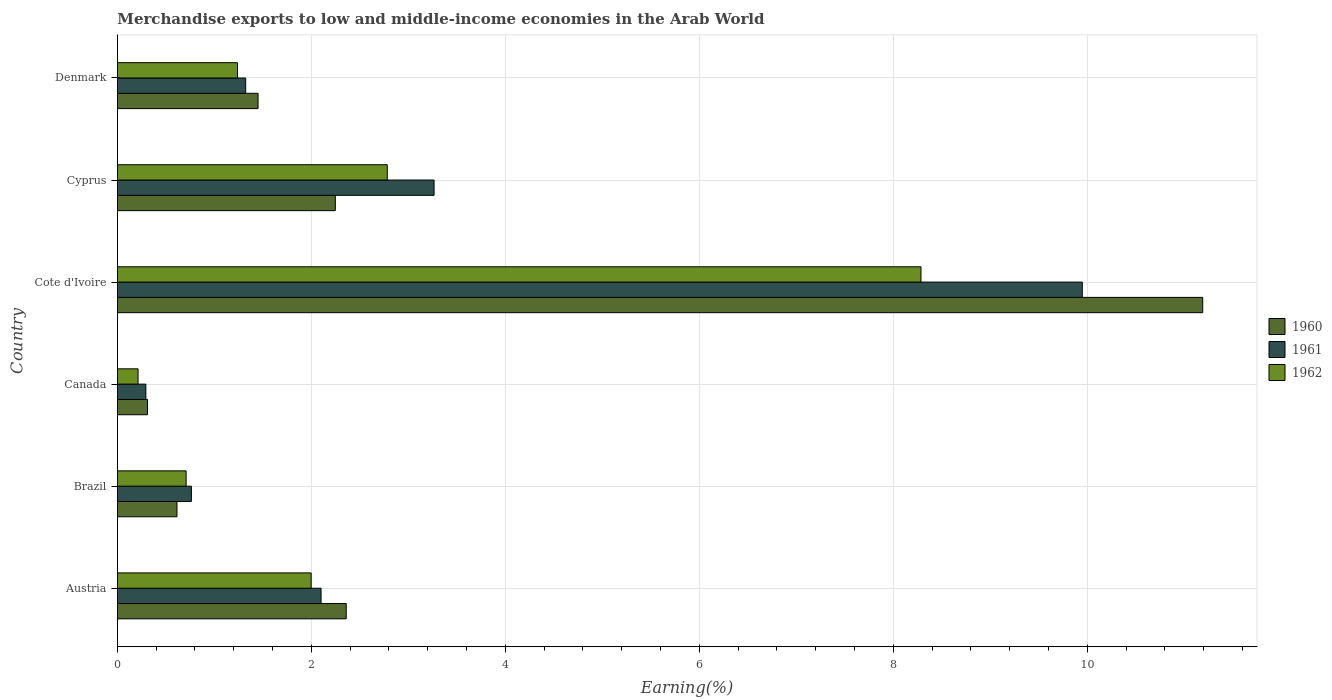How many different coloured bars are there?
Your answer should be compact. 3. How many groups of bars are there?
Provide a succinct answer. 6. Are the number of bars on each tick of the Y-axis equal?
Offer a very short reply. Yes. How many bars are there on the 1st tick from the top?
Keep it short and to the point. 3. In how many cases, is the number of bars for a given country not equal to the number of legend labels?
Keep it short and to the point. 0. What is the percentage of amount earned from merchandise exports in 1960 in Brazil?
Make the answer very short. 0.61. Across all countries, what is the maximum percentage of amount earned from merchandise exports in 1961?
Your answer should be compact. 9.95. Across all countries, what is the minimum percentage of amount earned from merchandise exports in 1962?
Your answer should be compact. 0.21. In which country was the percentage of amount earned from merchandise exports in 1960 maximum?
Your response must be concise. Cote d'Ivoire. In which country was the percentage of amount earned from merchandise exports in 1962 minimum?
Provide a short and direct response. Canada. What is the total percentage of amount earned from merchandise exports in 1961 in the graph?
Provide a succinct answer. 17.69. What is the difference between the percentage of amount earned from merchandise exports in 1960 in Brazil and that in Cyprus?
Offer a terse response. -1.63. What is the difference between the percentage of amount earned from merchandise exports in 1960 in Cyprus and the percentage of amount earned from merchandise exports in 1961 in Brazil?
Make the answer very short. 1.48. What is the average percentage of amount earned from merchandise exports in 1962 per country?
Keep it short and to the point. 2.54. What is the difference between the percentage of amount earned from merchandise exports in 1961 and percentage of amount earned from merchandise exports in 1960 in Brazil?
Make the answer very short. 0.15. In how many countries, is the percentage of amount earned from merchandise exports in 1962 greater than 7.6 %?
Provide a short and direct response. 1. What is the ratio of the percentage of amount earned from merchandise exports in 1962 in Austria to that in Denmark?
Make the answer very short. 1.61. Is the percentage of amount earned from merchandise exports in 1960 in Brazil less than that in Canada?
Offer a very short reply. No. What is the difference between the highest and the second highest percentage of amount earned from merchandise exports in 1960?
Your answer should be very brief. 8.83. What is the difference between the highest and the lowest percentage of amount earned from merchandise exports in 1961?
Your answer should be compact. 9.66. In how many countries, is the percentage of amount earned from merchandise exports in 1960 greater than the average percentage of amount earned from merchandise exports in 1960 taken over all countries?
Keep it short and to the point. 1. Is the sum of the percentage of amount earned from merchandise exports in 1962 in Cyprus and Denmark greater than the maximum percentage of amount earned from merchandise exports in 1960 across all countries?
Make the answer very short. No. What does the 2nd bar from the top in Austria represents?
Ensure brevity in your answer.  1961. How many bars are there?
Your answer should be very brief. 18. Are all the bars in the graph horizontal?
Your answer should be compact. Yes. How many countries are there in the graph?
Keep it short and to the point. 6. What is the difference between two consecutive major ticks on the X-axis?
Give a very brief answer. 2. Where does the legend appear in the graph?
Offer a terse response. Center right. What is the title of the graph?
Provide a short and direct response. Merchandise exports to low and middle-income economies in the Arab World. Does "1966" appear as one of the legend labels in the graph?
Offer a very short reply. No. What is the label or title of the X-axis?
Give a very brief answer. Earning(%). What is the label or title of the Y-axis?
Offer a terse response. Country. What is the Earning(%) in 1960 in Austria?
Provide a short and direct response. 2.36. What is the Earning(%) of 1961 in Austria?
Make the answer very short. 2.1. What is the Earning(%) of 1962 in Austria?
Keep it short and to the point. 2. What is the Earning(%) in 1960 in Brazil?
Ensure brevity in your answer.  0.61. What is the Earning(%) of 1961 in Brazil?
Make the answer very short. 0.76. What is the Earning(%) of 1962 in Brazil?
Your answer should be compact. 0.71. What is the Earning(%) in 1960 in Canada?
Give a very brief answer. 0.31. What is the Earning(%) in 1961 in Canada?
Make the answer very short. 0.29. What is the Earning(%) in 1962 in Canada?
Your answer should be very brief. 0.21. What is the Earning(%) in 1960 in Cote d'Ivoire?
Keep it short and to the point. 11.19. What is the Earning(%) in 1961 in Cote d'Ivoire?
Offer a very short reply. 9.95. What is the Earning(%) in 1962 in Cote d'Ivoire?
Make the answer very short. 8.29. What is the Earning(%) in 1960 in Cyprus?
Your answer should be compact. 2.25. What is the Earning(%) in 1961 in Cyprus?
Your response must be concise. 3.27. What is the Earning(%) of 1962 in Cyprus?
Give a very brief answer. 2.78. What is the Earning(%) of 1960 in Denmark?
Your answer should be compact. 1.45. What is the Earning(%) of 1961 in Denmark?
Your answer should be compact. 1.32. What is the Earning(%) in 1962 in Denmark?
Provide a short and direct response. 1.24. Across all countries, what is the maximum Earning(%) of 1960?
Give a very brief answer. 11.19. Across all countries, what is the maximum Earning(%) in 1961?
Give a very brief answer. 9.95. Across all countries, what is the maximum Earning(%) of 1962?
Keep it short and to the point. 8.29. Across all countries, what is the minimum Earning(%) in 1960?
Offer a terse response. 0.31. Across all countries, what is the minimum Earning(%) in 1961?
Provide a short and direct response. 0.29. Across all countries, what is the minimum Earning(%) in 1962?
Provide a succinct answer. 0.21. What is the total Earning(%) in 1960 in the graph?
Make the answer very short. 18.17. What is the total Earning(%) in 1961 in the graph?
Offer a terse response. 17.69. What is the total Earning(%) in 1962 in the graph?
Your answer should be very brief. 15.23. What is the difference between the Earning(%) of 1960 in Austria and that in Brazil?
Offer a terse response. 1.75. What is the difference between the Earning(%) of 1961 in Austria and that in Brazil?
Your answer should be compact. 1.34. What is the difference between the Earning(%) in 1962 in Austria and that in Brazil?
Your answer should be compact. 1.29. What is the difference between the Earning(%) of 1960 in Austria and that in Canada?
Ensure brevity in your answer.  2.05. What is the difference between the Earning(%) in 1961 in Austria and that in Canada?
Your response must be concise. 1.81. What is the difference between the Earning(%) in 1962 in Austria and that in Canada?
Keep it short and to the point. 1.78. What is the difference between the Earning(%) in 1960 in Austria and that in Cote d'Ivoire?
Your answer should be very brief. -8.83. What is the difference between the Earning(%) in 1961 in Austria and that in Cote d'Ivoire?
Provide a short and direct response. -7.85. What is the difference between the Earning(%) of 1962 in Austria and that in Cote d'Ivoire?
Your answer should be compact. -6.29. What is the difference between the Earning(%) in 1960 in Austria and that in Cyprus?
Ensure brevity in your answer.  0.11. What is the difference between the Earning(%) in 1961 in Austria and that in Cyprus?
Give a very brief answer. -1.17. What is the difference between the Earning(%) of 1962 in Austria and that in Cyprus?
Ensure brevity in your answer.  -0.78. What is the difference between the Earning(%) in 1960 in Austria and that in Denmark?
Offer a very short reply. 0.91. What is the difference between the Earning(%) in 1961 in Austria and that in Denmark?
Offer a very short reply. 0.78. What is the difference between the Earning(%) of 1962 in Austria and that in Denmark?
Make the answer very short. 0.76. What is the difference between the Earning(%) in 1960 in Brazil and that in Canada?
Give a very brief answer. 0.3. What is the difference between the Earning(%) in 1961 in Brazil and that in Canada?
Make the answer very short. 0.47. What is the difference between the Earning(%) in 1962 in Brazil and that in Canada?
Your answer should be very brief. 0.5. What is the difference between the Earning(%) in 1960 in Brazil and that in Cote d'Ivoire?
Your answer should be compact. -10.58. What is the difference between the Earning(%) of 1961 in Brazil and that in Cote d'Ivoire?
Offer a very short reply. -9.19. What is the difference between the Earning(%) in 1962 in Brazil and that in Cote d'Ivoire?
Offer a very short reply. -7.58. What is the difference between the Earning(%) in 1960 in Brazil and that in Cyprus?
Offer a terse response. -1.63. What is the difference between the Earning(%) in 1961 in Brazil and that in Cyprus?
Your response must be concise. -2.5. What is the difference between the Earning(%) of 1962 in Brazil and that in Cyprus?
Your answer should be compact. -2.07. What is the difference between the Earning(%) of 1960 in Brazil and that in Denmark?
Provide a succinct answer. -0.84. What is the difference between the Earning(%) of 1961 in Brazil and that in Denmark?
Ensure brevity in your answer.  -0.56. What is the difference between the Earning(%) in 1962 in Brazil and that in Denmark?
Provide a succinct answer. -0.53. What is the difference between the Earning(%) in 1960 in Canada and that in Cote d'Ivoire?
Give a very brief answer. -10.88. What is the difference between the Earning(%) of 1961 in Canada and that in Cote d'Ivoire?
Keep it short and to the point. -9.66. What is the difference between the Earning(%) in 1962 in Canada and that in Cote d'Ivoire?
Ensure brevity in your answer.  -8.07. What is the difference between the Earning(%) of 1960 in Canada and that in Cyprus?
Give a very brief answer. -1.94. What is the difference between the Earning(%) of 1961 in Canada and that in Cyprus?
Give a very brief answer. -2.97. What is the difference between the Earning(%) of 1962 in Canada and that in Cyprus?
Your response must be concise. -2.57. What is the difference between the Earning(%) in 1960 in Canada and that in Denmark?
Your answer should be compact. -1.14. What is the difference between the Earning(%) in 1961 in Canada and that in Denmark?
Keep it short and to the point. -1.03. What is the difference between the Earning(%) in 1962 in Canada and that in Denmark?
Give a very brief answer. -1.03. What is the difference between the Earning(%) of 1960 in Cote d'Ivoire and that in Cyprus?
Your answer should be very brief. 8.94. What is the difference between the Earning(%) in 1961 in Cote d'Ivoire and that in Cyprus?
Provide a succinct answer. 6.68. What is the difference between the Earning(%) in 1962 in Cote d'Ivoire and that in Cyprus?
Keep it short and to the point. 5.5. What is the difference between the Earning(%) in 1960 in Cote d'Ivoire and that in Denmark?
Offer a very short reply. 9.74. What is the difference between the Earning(%) of 1961 in Cote d'Ivoire and that in Denmark?
Ensure brevity in your answer.  8.63. What is the difference between the Earning(%) in 1962 in Cote d'Ivoire and that in Denmark?
Offer a terse response. 7.05. What is the difference between the Earning(%) of 1960 in Cyprus and that in Denmark?
Keep it short and to the point. 0.8. What is the difference between the Earning(%) in 1961 in Cyprus and that in Denmark?
Your response must be concise. 1.94. What is the difference between the Earning(%) in 1962 in Cyprus and that in Denmark?
Offer a very short reply. 1.54. What is the difference between the Earning(%) in 1960 in Austria and the Earning(%) in 1961 in Brazil?
Ensure brevity in your answer.  1.6. What is the difference between the Earning(%) of 1960 in Austria and the Earning(%) of 1962 in Brazil?
Your response must be concise. 1.65. What is the difference between the Earning(%) in 1961 in Austria and the Earning(%) in 1962 in Brazil?
Provide a succinct answer. 1.39. What is the difference between the Earning(%) of 1960 in Austria and the Earning(%) of 1961 in Canada?
Your answer should be very brief. 2.07. What is the difference between the Earning(%) of 1960 in Austria and the Earning(%) of 1962 in Canada?
Keep it short and to the point. 2.15. What is the difference between the Earning(%) in 1961 in Austria and the Earning(%) in 1962 in Canada?
Give a very brief answer. 1.89. What is the difference between the Earning(%) of 1960 in Austria and the Earning(%) of 1961 in Cote d'Ivoire?
Offer a very short reply. -7.59. What is the difference between the Earning(%) of 1960 in Austria and the Earning(%) of 1962 in Cote d'Ivoire?
Provide a succinct answer. -5.93. What is the difference between the Earning(%) of 1961 in Austria and the Earning(%) of 1962 in Cote d'Ivoire?
Give a very brief answer. -6.19. What is the difference between the Earning(%) of 1960 in Austria and the Earning(%) of 1961 in Cyprus?
Keep it short and to the point. -0.91. What is the difference between the Earning(%) of 1960 in Austria and the Earning(%) of 1962 in Cyprus?
Your response must be concise. -0.42. What is the difference between the Earning(%) of 1961 in Austria and the Earning(%) of 1962 in Cyprus?
Give a very brief answer. -0.68. What is the difference between the Earning(%) in 1960 in Austria and the Earning(%) in 1961 in Denmark?
Provide a short and direct response. 1.04. What is the difference between the Earning(%) in 1960 in Austria and the Earning(%) in 1962 in Denmark?
Provide a succinct answer. 1.12. What is the difference between the Earning(%) in 1961 in Austria and the Earning(%) in 1962 in Denmark?
Your answer should be compact. 0.86. What is the difference between the Earning(%) in 1960 in Brazil and the Earning(%) in 1961 in Canada?
Your answer should be compact. 0.32. What is the difference between the Earning(%) in 1960 in Brazil and the Earning(%) in 1962 in Canada?
Keep it short and to the point. 0.4. What is the difference between the Earning(%) in 1961 in Brazil and the Earning(%) in 1962 in Canada?
Give a very brief answer. 0.55. What is the difference between the Earning(%) of 1960 in Brazil and the Earning(%) of 1961 in Cote d'Ivoire?
Provide a succinct answer. -9.34. What is the difference between the Earning(%) in 1960 in Brazil and the Earning(%) in 1962 in Cote d'Ivoire?
Keep it short and to the point. -7.67. What is the difference between the Earning(%) in 1961 in Brazil and the Earning(%) in 1962 in Cote d'Ivoire?
Your answer should be compact. -7.52. What is the difference between the Earning(%) of 1960 in Brazil and the Earning(%) of 1961 in Cyprus?
Make the answer very short. -2.65. What is the difference between the Earning(%) of 1960 in Brazil and the Earning(%) of 1962 in Cyprus?
Your response must be concise. -2.17. What is the difference between the Earning(%) of 1961 in Brazil and the Earning(%) of 1962 in Cyprus?
Your answer should be very brief. -2.02. What is the difference between the Earning(%) in 1960 in Brazil and the Earning(%) in 1961 in Denmark?
Give a very brief answer. -0.71. What is the difference between the Earning(%) of 1960 in Brazil and the Earning(%) of 1962 in Denmark?
Give a very brief answer. -0.62. What is the difference between the Earning(%) of 1961 in Brazil and the Earning(%) of 1962 in Denmark?
Keep it short and to the point. -0.48. What is the difference between the Earning(%) in 1960 in Canada and the Earning(%) in 1961 in Cote d'Ivoire?
Ensure brevity in your answer.  -9.64. What is the difference between the Earning(%) of 1960 in Canada and the Earning(%) of 1962 in Cote d'Ivoire?
Your answer should be very brief. -7.98. What is the difference between the Earning(%) in 1961 in Canada and the Earning(%) in 1962 in Cote d'Ivoire?
Offer a terse response. -7.99. What is the difference between the Earning(%) of 1960 in Canada and the Earning(%) of 1961 in Cyprus?
Offer a terse response. -2.95. What is the difference between the Earning(%) of 1960 in Canada and the Earning(%) of 1962 in Cyprus?
Offer a terse response. -2.47. What is the difference between the Earning(%) of 1961 in Canada and the Earning(%) of 1962 in Cyprus?
Provide a short and direct response. -2.49. What is the difference between the Earning(%) in 1960 in Canada and the Earning(%) in 1961 in Denmark?
Provide a short and direct response. -1.01. What is the difference between the Earning(%) in 1960 in Canada and the Earning(%) in 1962 in Denmark?
Provide a short and direct response. -0.93. What is the difference between the Earning(%) of 1961 in Canada and the Earning(%) of 1962 in Denmark?
Your answer should be compact. -0.95. What is the difference between the Earning(%) of 1960 in Cote d'Ivoire and the Earning(%) of 1961 in Cyprus?
Give a very brief answer. 7.93. What is the difference between the Earning(%) of 1960 in Cote d'Ivoire and the Earning(%) of 1962 in Cyprus?
Your answer should be very brief. 8.41. What is the difference between the Earning(%) in 1961 in Cote d'Ivoire and the Earning(%) in 1962 in Cyprus?
Ensure brevity in your answer.  7.17. What is the difference between the Earning(%) of 1960 in Cote d'Ivoire and the Earning(%) of 1961 in Denmark?
Your answer should be very brief. 9.87. What is the difference between the Earning(%) in 1960 in Cote d'Ivoire and the Earning(%) in 1962 in Denmark?
Provide a succinct answer. 9.95. What is the difference between the Earning(%) in 1961 in Cote d'Ivoire and the Earning(%) in 1962 in Denmark?
Offer a terse response. 8.71. What is the difference between the Earning(%) of 1960 in Cyprus and the Earning(%) of 1961 in Denmark?
Give a very brief answer. 0.92. What is the difference between the Earning(%) of 1960 in Cyprus and the Earning(%) of 1962 in Denmark?
Keep it short and to the point. 1.01. What is the difference between the Earning(%) in 1961 in Cyprus and the Earning(%) in 1962 in Denmark?
Offer a very short reply. 2.03. What is the average Earning(%) of 1960 per country?
Provide a succinct answer. 3.03. What is the average Earning(%) of 1961 per country?
Make the answer very short. 2.95. What is the average Earning(%) of 1962 per country?
Your answer should be compact. 2.54. What is the difference between the Earning(%) in 1960 and Earning(%) in 1961 in Austria?
Provide a short and direct response. 0.26. What is the difference between the Earning(%) of 1960 and Earning(%) of 1962 in Austria?
Your answer should be very brief. 0.36. What is the difference between the Earning(%) in 1961 and Earning(%) in 1962 in Austria?
Provide a short and direct response. 0.1. What is the difference between the Earning(%) of 1960 and Earning(%) of 1961 in Brazil?
Ensure brevity in your answer.  -0.15. What is the difference between the Earning(%) in 1960 and Earning(%) in 1962 in Brazil?
Your response must be concise. -0.09. What is the difference between the Earning(%) in 1961 and Earning(%) in 1962 in Brazil?
Your response must be concise. 0.05. What is the difference between the Earning(%) of 1960 and Earning(%) of 1961 in Canada?
Provide a short and direct response. 0.02. What is the difference between the Earning(%) of 1960 and Earning(%) of 1962 in Canada?
Your answer should be compact. 0.1. What is the difference between the Earning(%) of 1961 and Earning(%) of 1962 in Canada?
Offer a terse response. 0.08. What is the difference between the Earning(%) in 1960 and Earning(%) in 1961 in Cote d'Ivoire?
Your answer should be very brief. 1.24. What is the difference between the Earning(%) in 1960 and Earning(%) in 1962 in Cote d'Ivoire?
Offer a terse response. 2.91. What is the difference between the Earning(%) in 1961 and Earning(%) in 1962 in Cote d'Ivoire?
Give a very brief answer. 1.66. What is the difference between the Earning(%) of 1960 and Earning(%) of 1961 in Cyprus?
Provide a succinct answer. -1.02. What is the difference between the Earning(%) of 1960 and Earning(%) of 1962 in Cyprus?
Your answer should be very brief. -0.54. What is the difference between the Earning(%) of 1961 and Earning(%) of 1962 in Cyprus?
Your answer should be very brief. 0.48. What is the difference between the Earning(%) in 1960 and Earning(%) in 1961 in Denmark?
Your answer should be compact. 0.13. What is the difference between the Earning(%) of 1960 and Earning(%) of 1962 in Denmark?
Make the answer very short. 0.21. What is the difference between the Earning(%) of 1961 and Earning(%) of 1962 in Denmark?
Provide a short and direct response. 0.08. What is the ratio of the Earning(%) in 1960 in Austria to that in Brazil?
Offer a very short reply. 3.84. What is the ratio of the Earning(%) in 1961 in Austria to that in Brazil?
Your answer should be compact. 2.75. What is the ratio of the Earning(%) in 1962 in Austria to that in Brazil?
Offer a terse response. 2.82. What is the ratio of the Earning(%) in 1960 in Austria to that in Canada?
Ensure brevity in your answer.  7.59. What is the ratio of the Earning(%) in 1961 in Austria to that in Canada?
Make the answer very short. 7.16. What is the ratio of the Earning(%) of 1962 in Austria to that in Canada?
Provide a succinct answer. 9.38. What is the ratio of the Earning(%) of 1960 in Austria to that in Cote d'Ivoire?
Give a very brief answer. 0.21. What is the ratio of the Earning(%) in 1961 in Austria to that in Cote d'Ivoire?
Make the answer very short. 0.21. What is the ratio of the Earning(%) in 1962 in Austria to that in Cote d'Ivoire?
Offer a terse response. 0.24. What is the ratio of the Earning(%) in 1960 in Austria to that in Cyprus?
Keep it short and to the point. 1.05. What is the ratio of the Earning(%) in 1961 in Austria to that in Cyprus?
Offer a terse response. 0.64. What is the ratio of the Earning(%) in 1962 in Austria to that in Cyprus?
Offer a very short reply. 0.72. What is the ratio of the Earning(%) of 1960 in Austria to that in Denmark?
Your answer should be very brief. 1.63. What is the ratio of the Earning(%) of 1961 in Austria to that in Denmark?
Give a very brief answer. 1.59. What is the ratio of the Earning(%) of 1962 in Austria to that in Denmark?
Make the answer very short. 1.61. What is the ratio of the Earning(%) of 1960 in Brazil to that in Canada?
Offer a terse response. 1.98. What is the ratio of the Earning(%) of 1961 in Brazil to that in Canada?
Provide a short and direct response. 2.6. What is the ratio of the Earning(%) in 1962 in Brazil to that in Canada?
Make the answer very short. 3.33. What is the ratio of the Earning(%) in 1960 in Brazil to that in Cote d'Ivoire?
Make the answer very short. 0.05. What is the ratio of the Earning(%) in 1961 in Brazil to that in Cote d'Ivoire?
Ensure brevity in your answer.  0.08. What is the ratio of the Earning(%) in 1962 in Brazil to that in Cote d'Ivoire?
Give a very brief answer. 0.09. What is the ratio of the Earning(%) in 1960 in Brazil to that in Cyprus?
Give a very brief answer. 0.27. What is the ratio of the Earning(%) in 1961 in Brazil to that in Cyprus?
Provide a short and direct response. 0.23. What is the ratio of the Earning(%) in 1962 in Brazil to that in Cyprus?
Keep it short and to the point. 0.25. What is the ratio of the Earning(%) in 1960 in Brazil to that in Denmark?
Give a very brief answer. 0.42. What is the ratio of the Earning(%) in 1961 in Brazil to that in Denmark?
Ensure brevity in your answer.  0.58. What is the ratio of the Earning(%) of 1962 in Brazil to that in Denmark?
Offer a very short reply. 0.57. What is the ratio of the Earning(%) in 1960 in Canada to that in Cote d'Ivoire?
Provide a succinct answer. 0.03. What is the ratio of the Earning(%) of 1961 in Canada to that in Cote d'Ivoire?
Your response must be concise. 0.03. What is the ratio of the Earning(%) of 1962 in Canada to that in Cote d'Ivoire?
Keep it short and to the point. 0.03. What is the ratio of the Earning(%) in 1960 in Canada to that in Cyprus?
Offer a terse response. 0.14. What is the ratio of the Earning(%) of 1961 in Canada to that in Cyprus?
Offer a terse response. 0.09. What is the ratio of the Earning(%) of 1962 in Canada to that in Cyprus?
Make the answer very short. 0.08. What is the ratio of the Earning(%) in 1960 in Canada to that in Denmark?
Ensure brevity in your answer.  0.21. What is the ratio of the Earning(%) in 1961 in Canada to that in Denmark?
Make the answer very short. 0.22. What is the ratio of the Earning(%) in 1962 in Canada to that in Denmark?
Offer a terse response. 0.17. What is the ratio of the Earning(%) in 1960 in Cote d'Ivoire to that in Cyprus?
Offer a terse response. 4.98. What is the ratio of the Earning(%) in 1961 in Cote d'Ivoire to that in Cyprus?
Give a very brief answer. 3.05. What is the ratio of the Earning(%) in 1962 in Cote d'Ivoire to that in Cyprus?
Provide a succinct answer. 2.98. What is the ratio of the Earning(%) of 1960 in Cote d'Ivoire to that in Denmark?
Ensure brevity in your answer.  7.72. What is the ratio of the Earning(%) of 1961 in Cote d'Ivoire to that in Denmark?
Provide a succinct answer. 7.52. What is the ratio of the Earning(%) in 1962 in Cote d'Ivoire to that in Denmark?
Provide a short and direct response. 6.69. What is the ratio of the Earning(%) in 1960 in Cyprus to that in Denmark?
Make the answer very short. 1.55. What is the ratio of the Earning(%) in 1961 in Cyprus to that in Denmark?
Make the answer very short. 2.47. What is the ratio of the Earning(%) in 1962 in Cyprus to that in Denmark?
Your response must be concise. 2.25. What is the difference between the highest and the second highest Earning(%) in 1960?
Your response must be concise. 8.83. What is the difference between the highest and the second highest Earning(%) in 1961?
Your answer should be very brief. 6.68. What is the difference between the highest and the second highest Earning(%) in 1962?
Offer a terse response. 5.5. What is the difference between the highest and the lowest Earning(%) of 1960?
Ensure brevity in your answer.  10.88. What is the difference between the highest and the lowest Earning(%) of 1961?
Provide a short and direct response. 9.66. What is the difference between the highest and the lowest Earning(%) in 1962?
Offer a terse response. 8.07. 